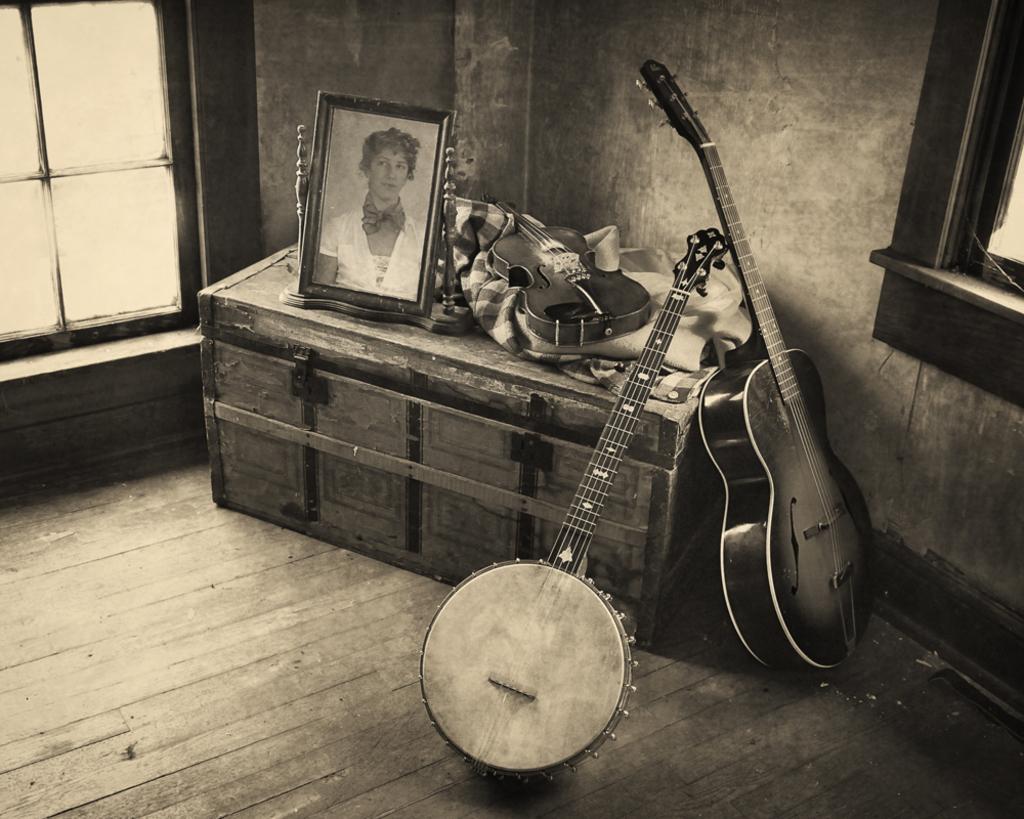Please provide a concise description of this image. A black and white picture. On this box there is a cloth, guitar and a picture of a woman. Beside this box there are guitars. This is window. 